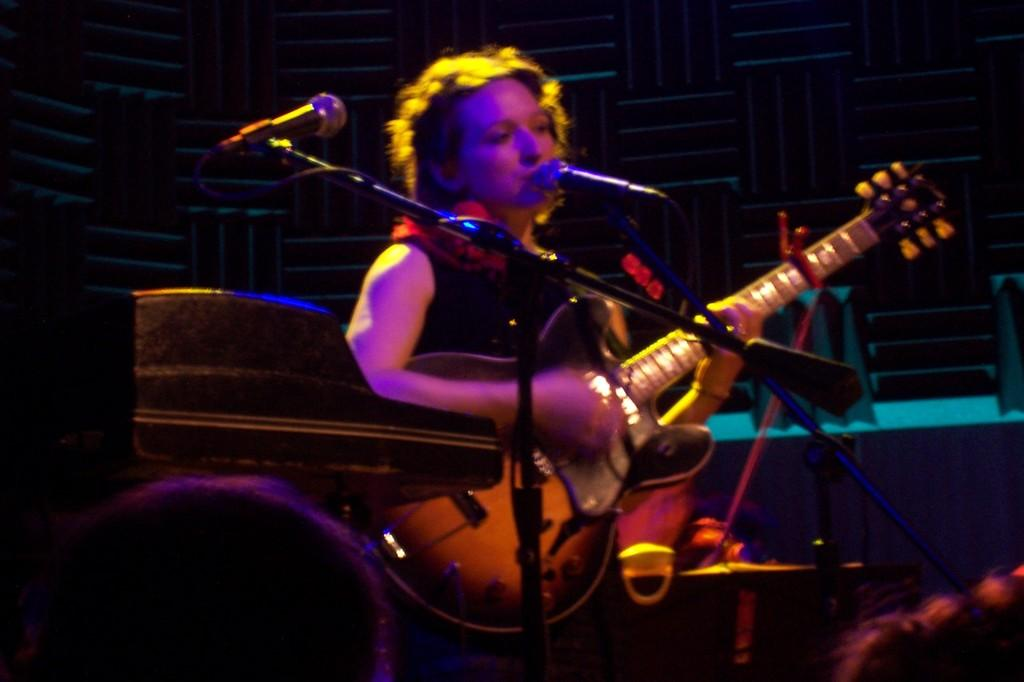What is the person in the image doing? The person is singing and playing guitar. How are the microphones positioned in relation to the person? There are 2 microphones in front of the person. What color is the background behind the person? The background behind the person is black. What colors of light are falling on the person? Pink and yellow lights are falling on the person. Can you see the person's brain while they are playing the guitar in the image? No, the person's brain is not visible in the image. How does the sky look like in the image? There is no sky visible in the image, as it has a black background. 